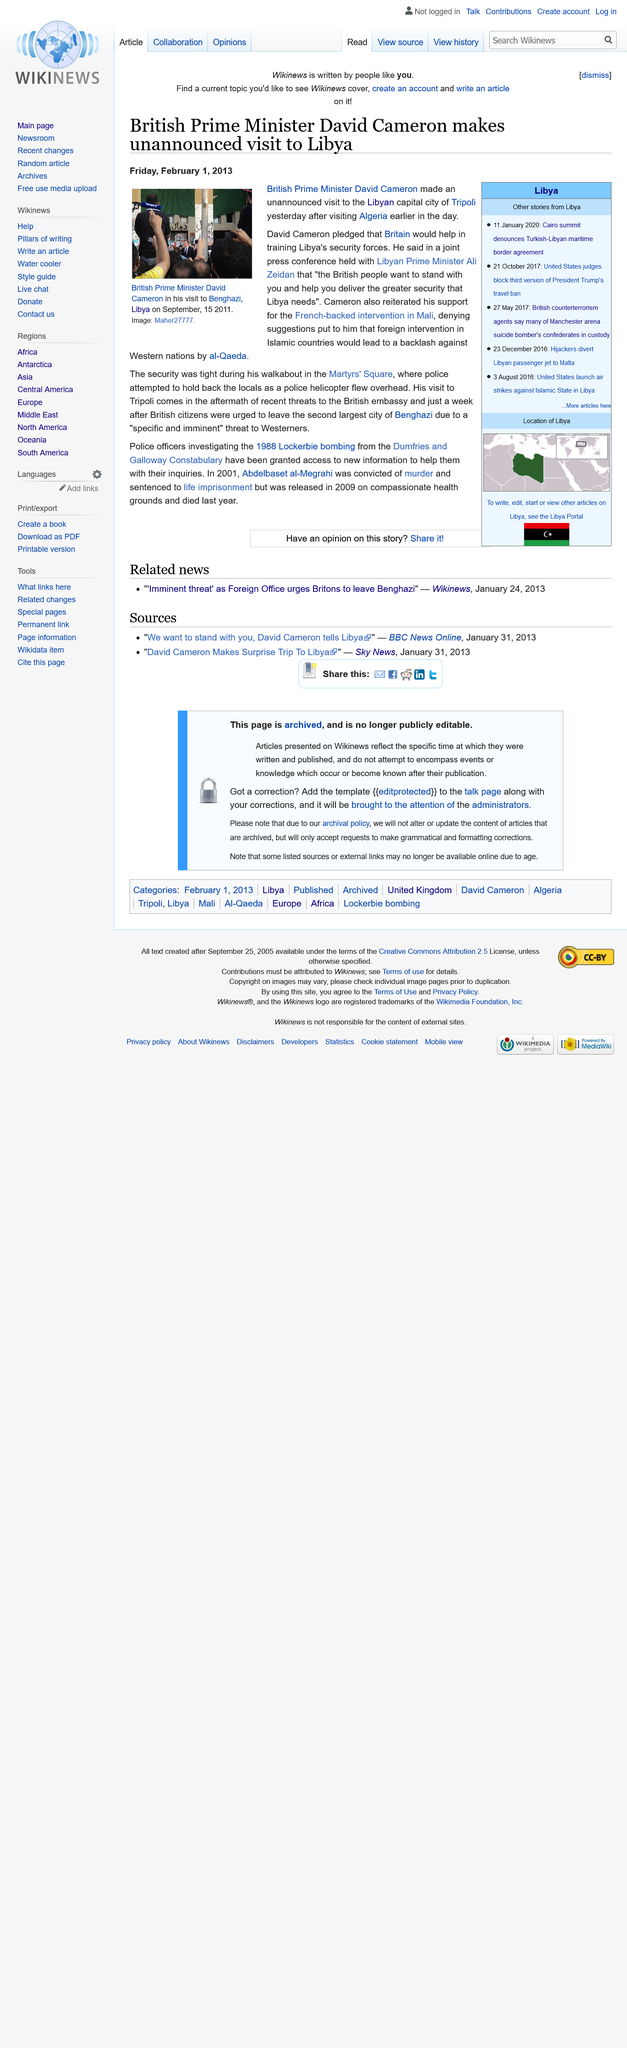Identify some key points in this picture. The article on David Cameron's unannounced visit was published on Friday, February 1, 2013. The capital city of Libya is Tripoli, and it is known for being the largest city in the country. On December 23, 2016, a Libyan passenger jet was hijacked and diverted to Malta, leading to a separate story of political turmoil and conflict in the country. 